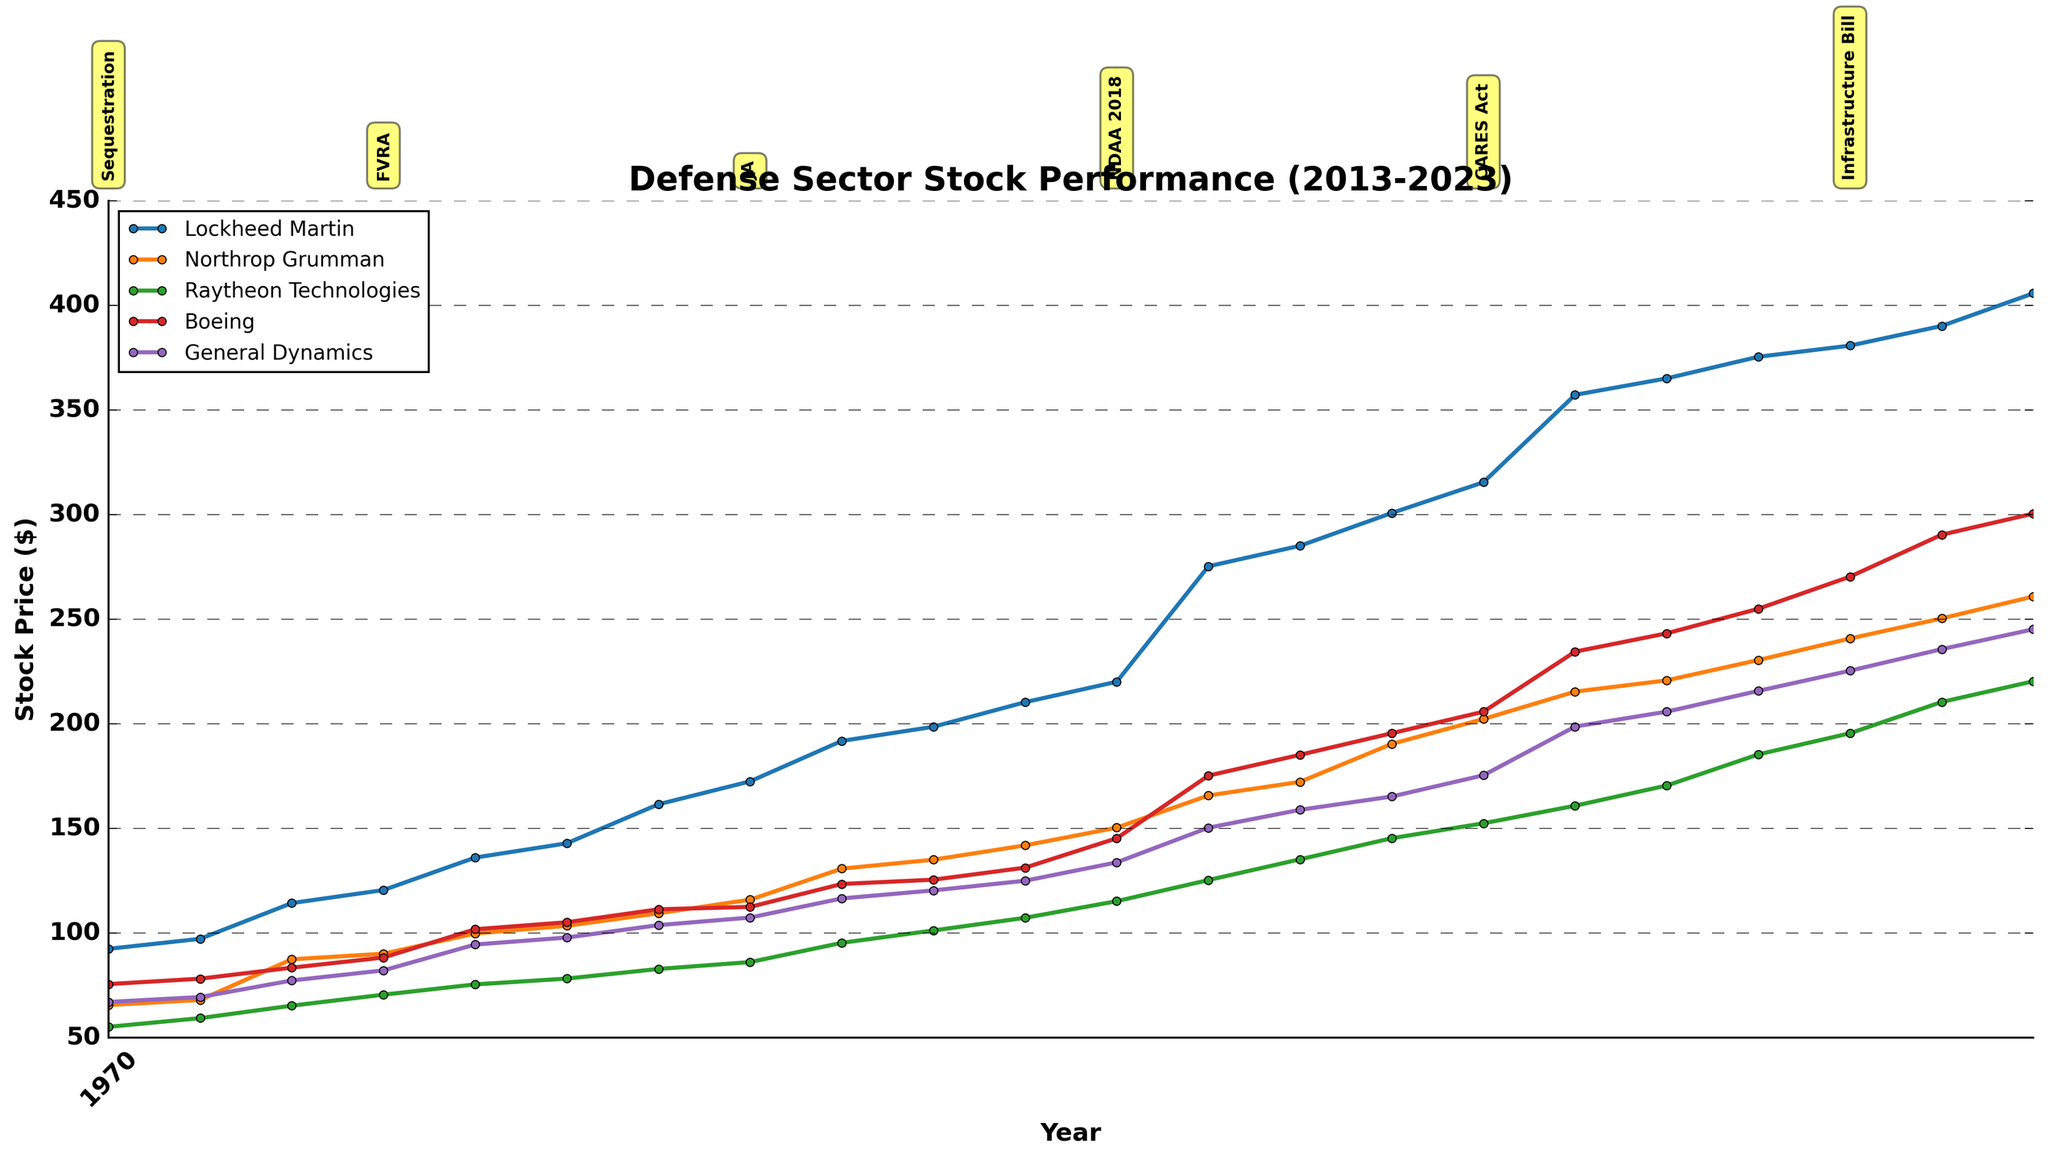What's the title of the figure? The title is usually at the top of the plot and describes what the chart is about. Looking at the top of the figure should reveal this information.
Answer: Defense Sector Stock Performance (2013-2023) Which company had the highest stock price in January 2023? Look for the data points plotted in January 2023 and identify which company has the highest value.
Answer: Lockheed Martin During which policy change did Boeing's stock price increase considerably around the mid-point of the covered years? Identify the policy changes marked on the plot and observe Boeing's stock price trend during those periods.
Answer: NDAA 2018 What is the difference in stock price for Northrop Grumman between January 2013 and June 2023? Locate Northrop Grumman's stock prices for the two dates and subtract the earlier value from the later value. Northrop Grumman's stock price in January 2013 is 65.60, and in June 2023, it is 260.85. (260.85 - 65.60) = 195.25
Answer: 195.25 Which company shows the most significant stock price increase from the beginning to the end of the period covered? Compare the stock prices of all companies in January 2013 and June 2023, then calculate the increase for each company and identify the highest one.
Answer: Lockheed Martin How does the stock price trend around March 2020 for the companies, likely due to the COVID-19 pandemic and the subsequent CARES Act in June 2020? Focus on the stock price values in early 2020 and see how they change notably around March to June 2020, especially at the point marked as CARES Act.
Answer: Prices increased Which company had the most stable stock price over the decade, showing minimal fluctuation? Observe the plot and identify the company whose stock price trend line is the smoothest and shows the least volatility.
Answer: General Dynamics What was the average stock price of Raytheon Technologies in the years when policy changes were marked? Identify the years of policy changes, then find Raytheon’s stock prices in those years and average them. The relevant years and stock prices are: 2013 (55.16), 2014 (70.54), 2016 (86.12), 2018 (115.23), 2020 (152.45), 2022 (195.50). The average is (55.16 + 70.54 + 86.12 + 115.23 + 152.45 + 195.50) / 6.
Answer: 112.50 Which policy change appears to correspond with the highest stock price increase for Lockheed Martin? Look at the dates and labels for policy changes on the plot. Observe the corresponding stock price spikes for Lockheed Martin around those dates.
Answer: Sequestration How much did Boeing's stock price change between the Sequestration policy and the CARES Act? Identify Boeing's stock prices during the Sequestration policy (75.59) and CARES Act (205.78), then calculate the difference.
Answer: 130.19 